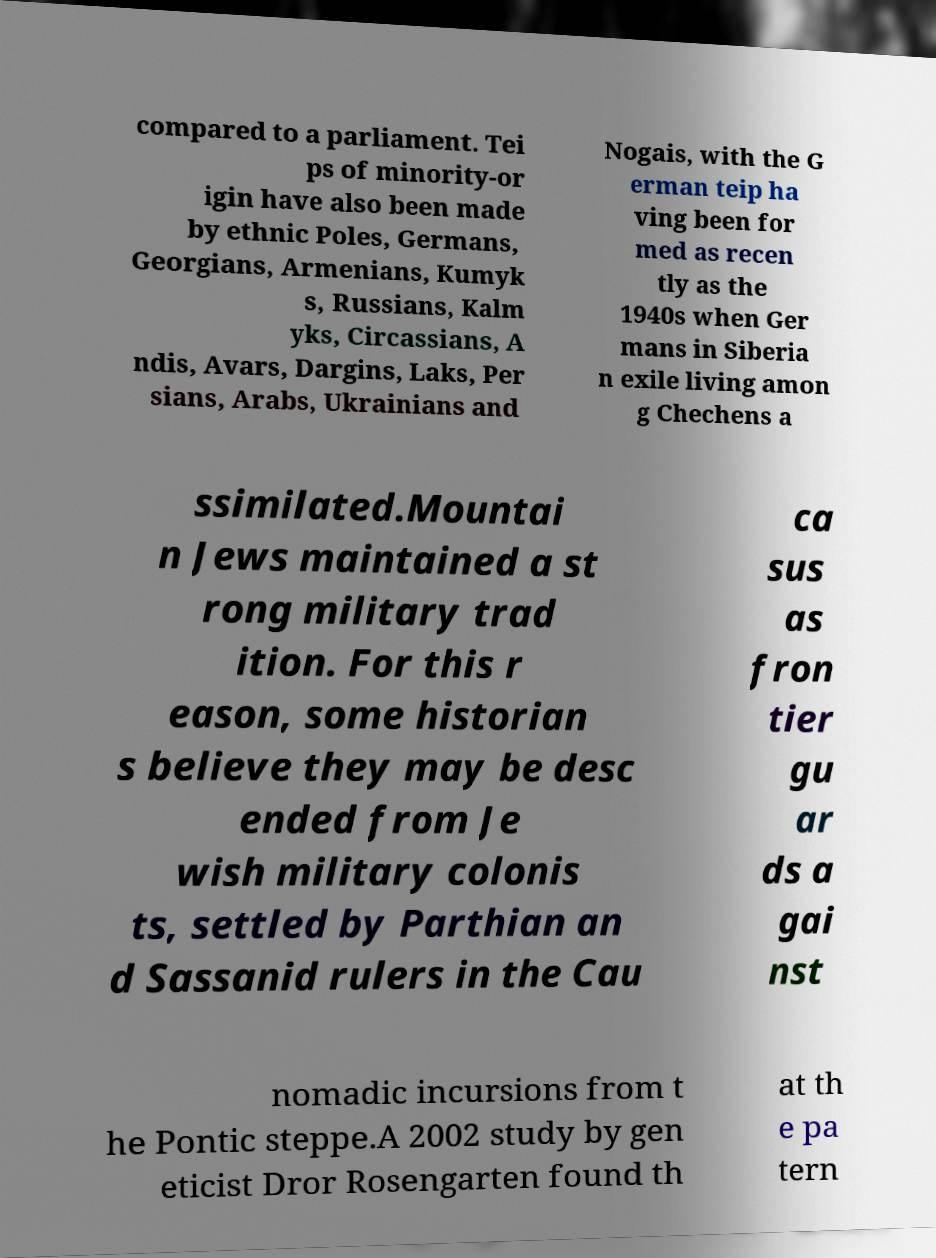What messages or text are displayed in this image? I need them in a readable, typed format. compared to a parliament. Tei ps of minority-or igin have also been made by ethnic Poles, Germans, Georgians, Armenians, Kumyk s, Russians, Kalm yks, Circassians, A ndis, Avars, Dargins, Laks, Per sians, Arabs, Ukrainians and Nogais, with the G erman teip ha ving been for med as recen tly as the 1940s when Ger mans in Siberia n exile living amon g Chechens a ssimilated.Mountai n Jews maintained a st rong military trad ition. For this r eason, some historian s believe they may be desc ended from Je wish military colonis ts, settled by Parthian an d Sassanid rulers in the Cau ca sus as fron tier gu ar ds a gai nst nomadic incursions from t he Pontic steppe.A 2002 study by gen eticist Dror Rosengarten found th at th e pa tern 